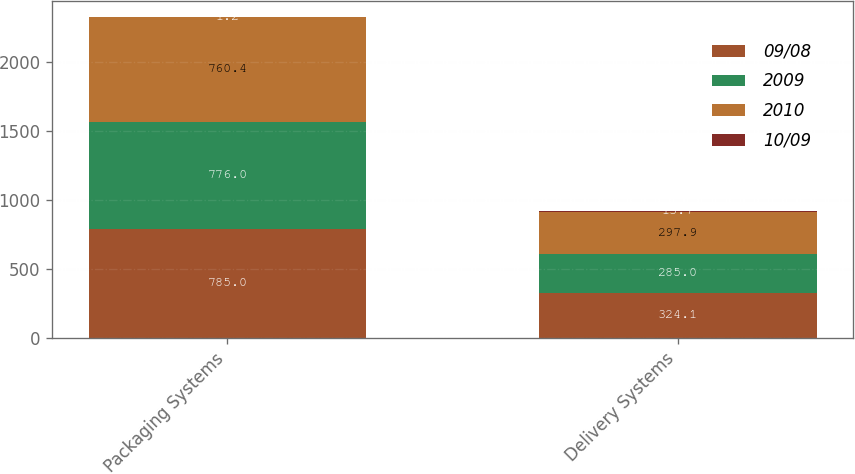Convert chart. <chart><loc_0><loc_0><loc_500><loc_500><stacked_bar_chart><ecel><fcel>Packaging Systems<fcel>Delivery Systems<nl><fcel>09/08<fcel>785<fcel>324.1<nl><fcel>2009<fcel>776<fcel>285<nl><fcel>2010<fcel>760.4<fcel>297.9<nl><fcel>10/09<fcel>1.2<fcel>13.7<nl></chart> 